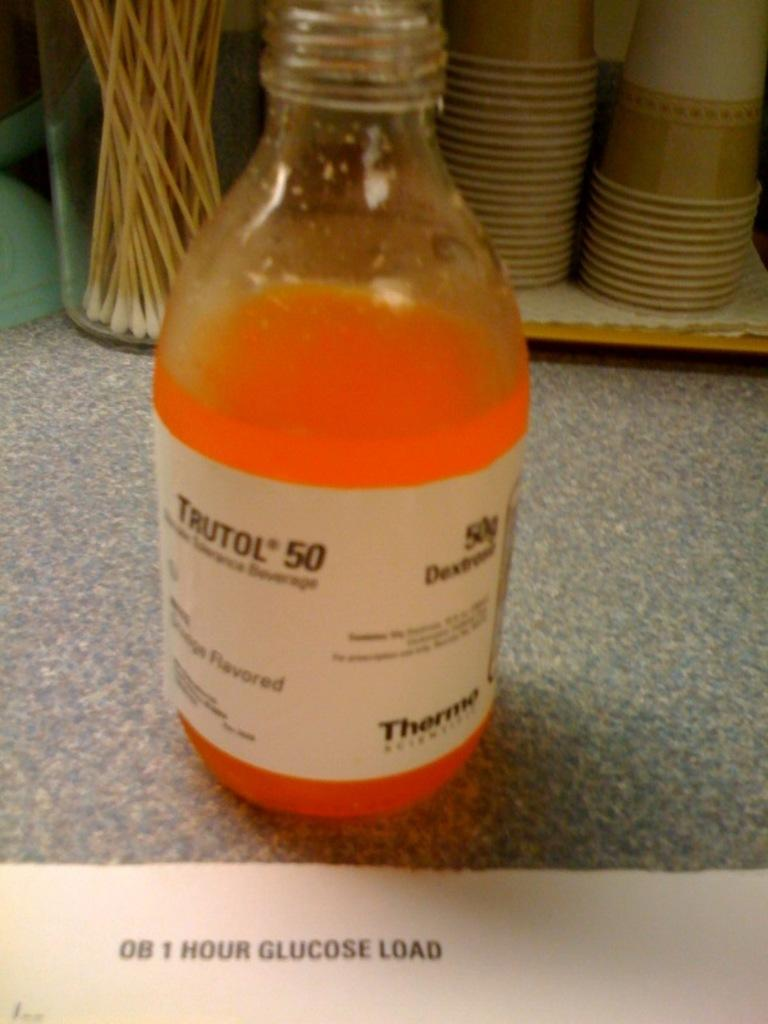<image>
Write a terse but informative summary of the picture. A bottle of Trutol gluclose drink is sitting in front of paper cups. 